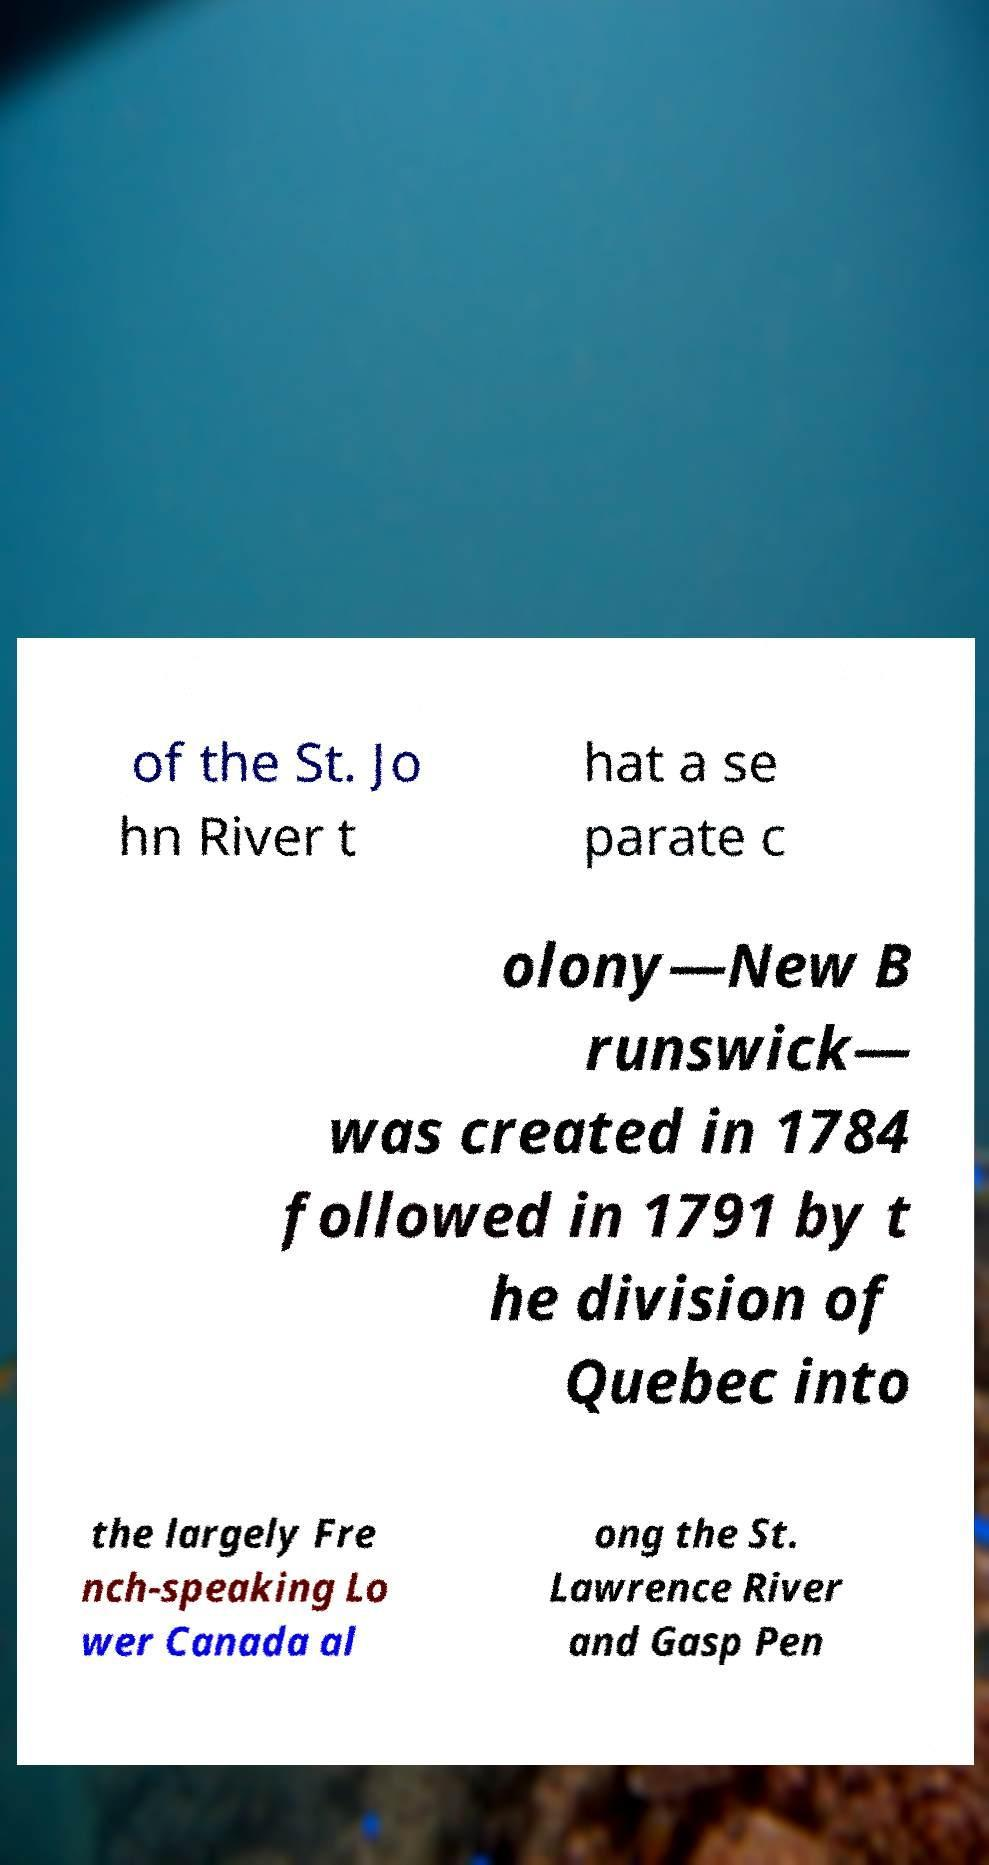Can you read and provide the text displayed in the image?This photo seems to have some interesting text. Can you extract and type it out for me? of the St. Jo hn River t hat a se parate c olony—New B runswick— was created in 1784 followed in 1791 by t he division of Quebec into the largely Fre nch-speaking Lo wer Canada al ong the St. Lawrence River and Gasp Pen 